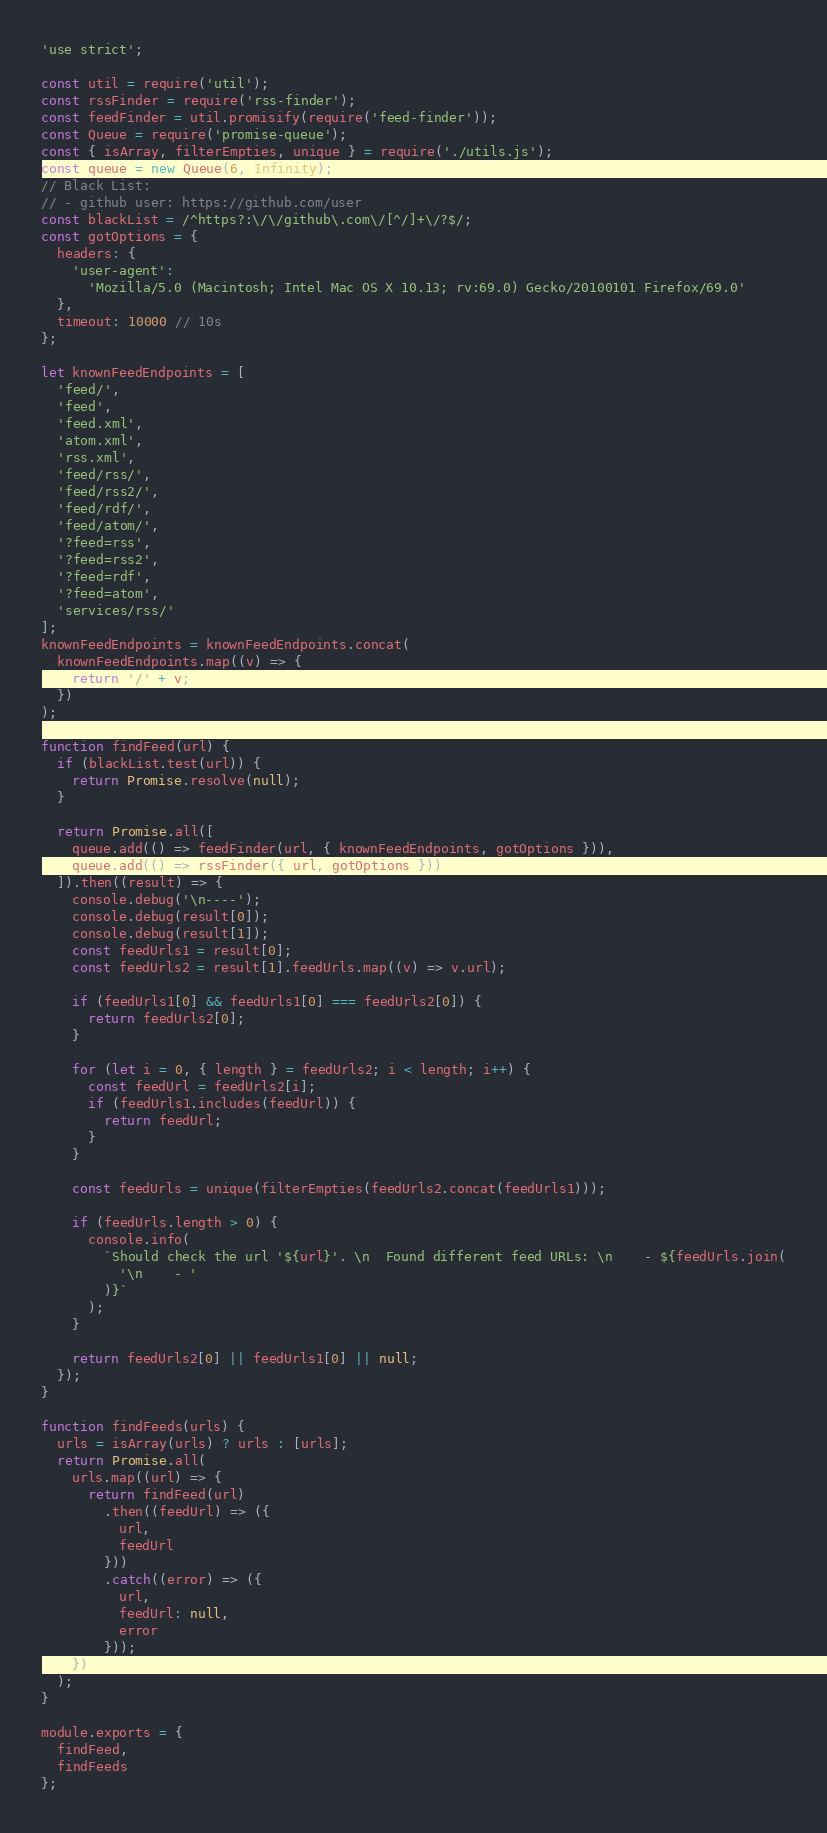Convert code to text. <code><loc_0><loc_0><loc_500><loc_500><_JavaScript_>'use strict';

const util = require('util');
const rssFinder = require('rss-finder');
const feedFinder = util.promisify(require('feed-finder'));
const Queue = require('promise-queue');
const { isArray, filterEmpties, unique } = require('./utils.js');
const queue = new Queue(6, Infinity);
// Black List:
// - github user: https://github.com/user
const blackList = /^https?:\/\/github\.com\/[^/]+\/?$/;
const gotOptions = {
  headers: {
    'user-agent':
      'Mozilla/5.0 (Macintosh; Intel Mac OS X 10.13; rv:69.0) Gecko/20100101 Firefox/69.0'
  },
  timeout: 10000 // 10s
};

let knownFeedEndpoints = [
  'feed/',
  'feed',
  'feed.xml',
  'atom.xml',
  'rss.xml',
  'feed/rss/',
  'feed/rss2/',
  'feed/rdf/',
  'feed/atom/',
  '?feed=rss',
  '?feed=rss2',
  '?feed=rdf',
  '?feed=atom',
  'services/rss/'
];
knownFeedEndpoints = knownFeedEndpoints.concat(
  knownFeedEndpoints.map((v) => {
    return '/' + v;
  })
);

function findFeed(url) {
  if (blackList.test(url)) {
    return Promise.resolve(null);
  }

  return Promise.all([
    queue.add(() => feedFinder(url, { knownFeedEndpoints, gotOptions })),
    queue.add(() => rssFinder({ url, gotOptions }))
  ]).then((result) => {
    console.debug('\n----');
    console.debug(result[0]);
    console.debug(result[1]);
    const feedUrls1 = result[0];
    const feedUrls2 = result[1].feedUrls.map((v) => v.url);

    if (feedUrls1[0] && feedUrls1[0] === feedUrls2[0]) {
      return feedUrls2[0];
    }

    for (let i = 0, { length } = feedUrls2; i < length; i++) {
      const feedUrl = feedUrls2[i];
      if (feedUrls1.includes(feedUrl)) {
        return feedUrl;
      }
    }

    const feedUrls = unique(filterEmpties(feedUrls2.concat(feedUrls1)));

    if (feedUrls.length > 0) {
      console.info(
        `Should check the url '${url}'. \n  Found different feed URLs: \n    - ${feedUrls.join(
          '\n    - '
        )}`
      );
    }

    return feedUrls2[0] || feedUrls1[0] || null;
  });
}

function findFeeds(urls) {
  urls = isArray(urls) ? urls : [urls];
  return Promise.all(
    urls.map((url) => {
      return findFeed(url)
        .then((feedUrl) => ({
          url,
          feedUrl
        }))
        .catch((error) => ({
          url,
          feedUrl: null,
          error
        }));
    })
  );
}

module.exports = {
  findFeed,
  findFeeds
};
</code> 